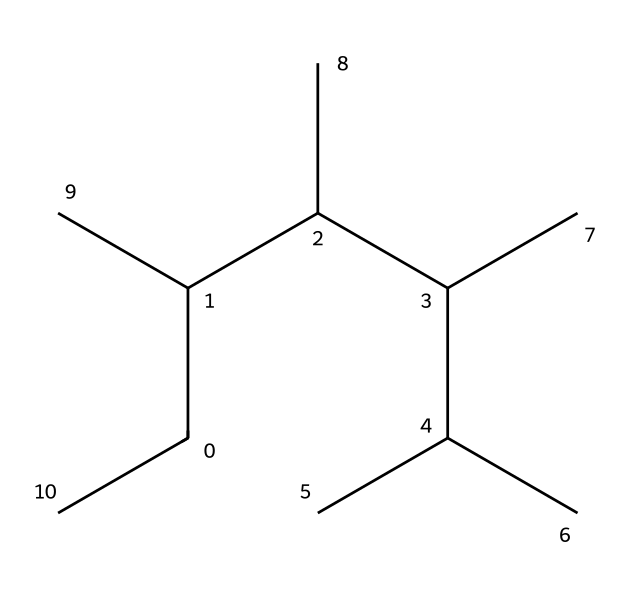What is the molecular formula derived from this SMILES representation? By analyzing the SMILES representation, we can differentiate the carbon and hydrogen atoms present. Each 'C' represents a carbon atom, and because there are 15 'C's, we start with C15. Counting the implied hydrogen atoms, we apply the tetravalency rule for carbon, leading to C15H32.
Answer: C15H32 How many carbon atoms are in the structure? The SMILES representation contains 15 'C' symbols, indicating there are 15 carbon atoms present in the structure.
Answer: 15 What type of polymer is indicated by this chemical structure? The presence of a long chain of carbon atoms suggests that this compound is likely a hydrocarbon polymer, which is characteristic of aliphatic polymers like polyethylene, commonly used in fibers.
Answer: aliphatic polymer What is the degree of saturation for this chemical? The structure contains no double or triple bonds, resulting in full saturation of carbon. Consequently, the degree of saturation is total or 100%.
Answer: saturated How many hydrogen atoms would be needed to produce a stable structure? Given the 15 carbon atoms and applying the tetravalency rule, including the maximum bonding with hydrogen atoms, suggests that 32 hydrogen atoms would be necessary for stability.
Answer: 32 Does this chemical structure exhibit any functional groups? The SMILES representation only consists of carbon and hydrogen atoms without any additional elements or specific functional groups, indicating it has no functional groups.
Answer: no What properties make this fiber suitable for high-end laptop chassis? The long-chain hydrocarbon structure contributes to high strength and lightweight characteristics, ideal for applications in high-end products like laptop chassis.
Answer: high strength, lightweight 